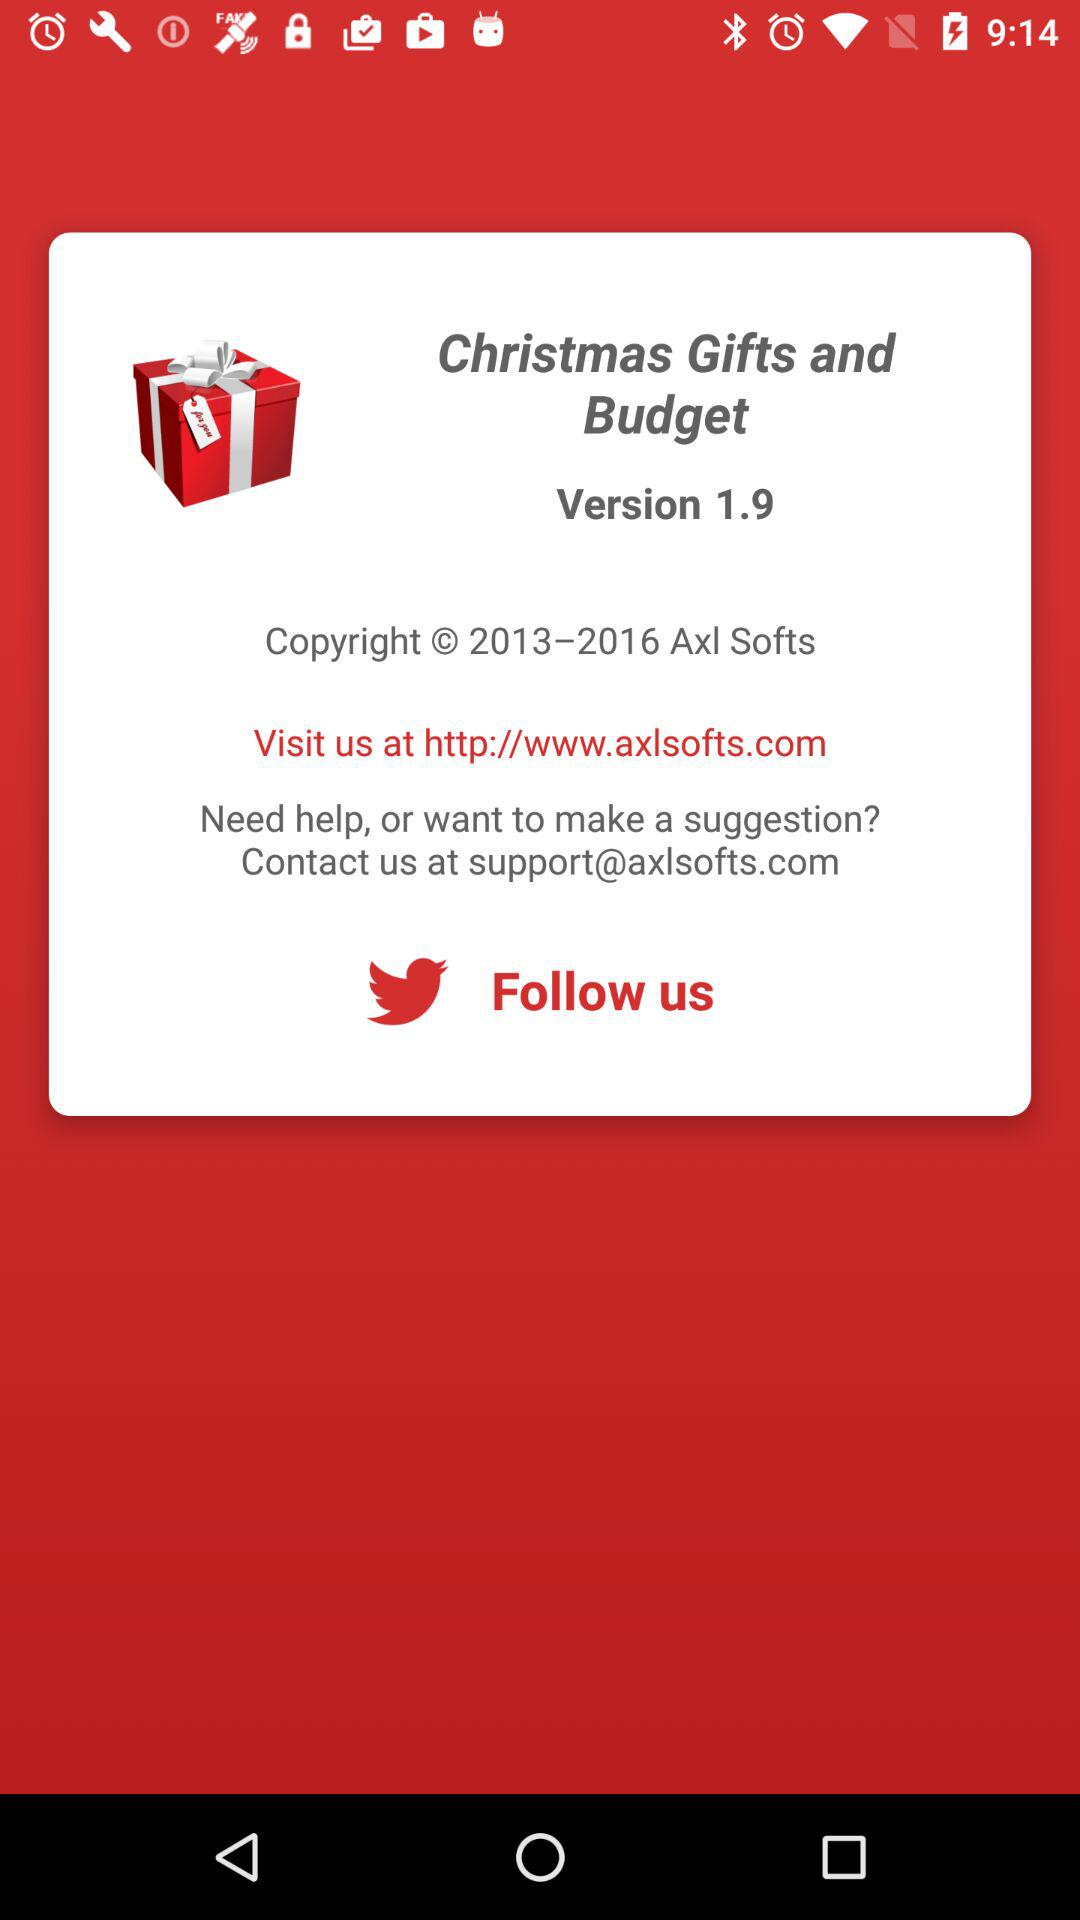What is the user's name?
When the provided information is insufficient, respond with <no answer>. <no answer> 